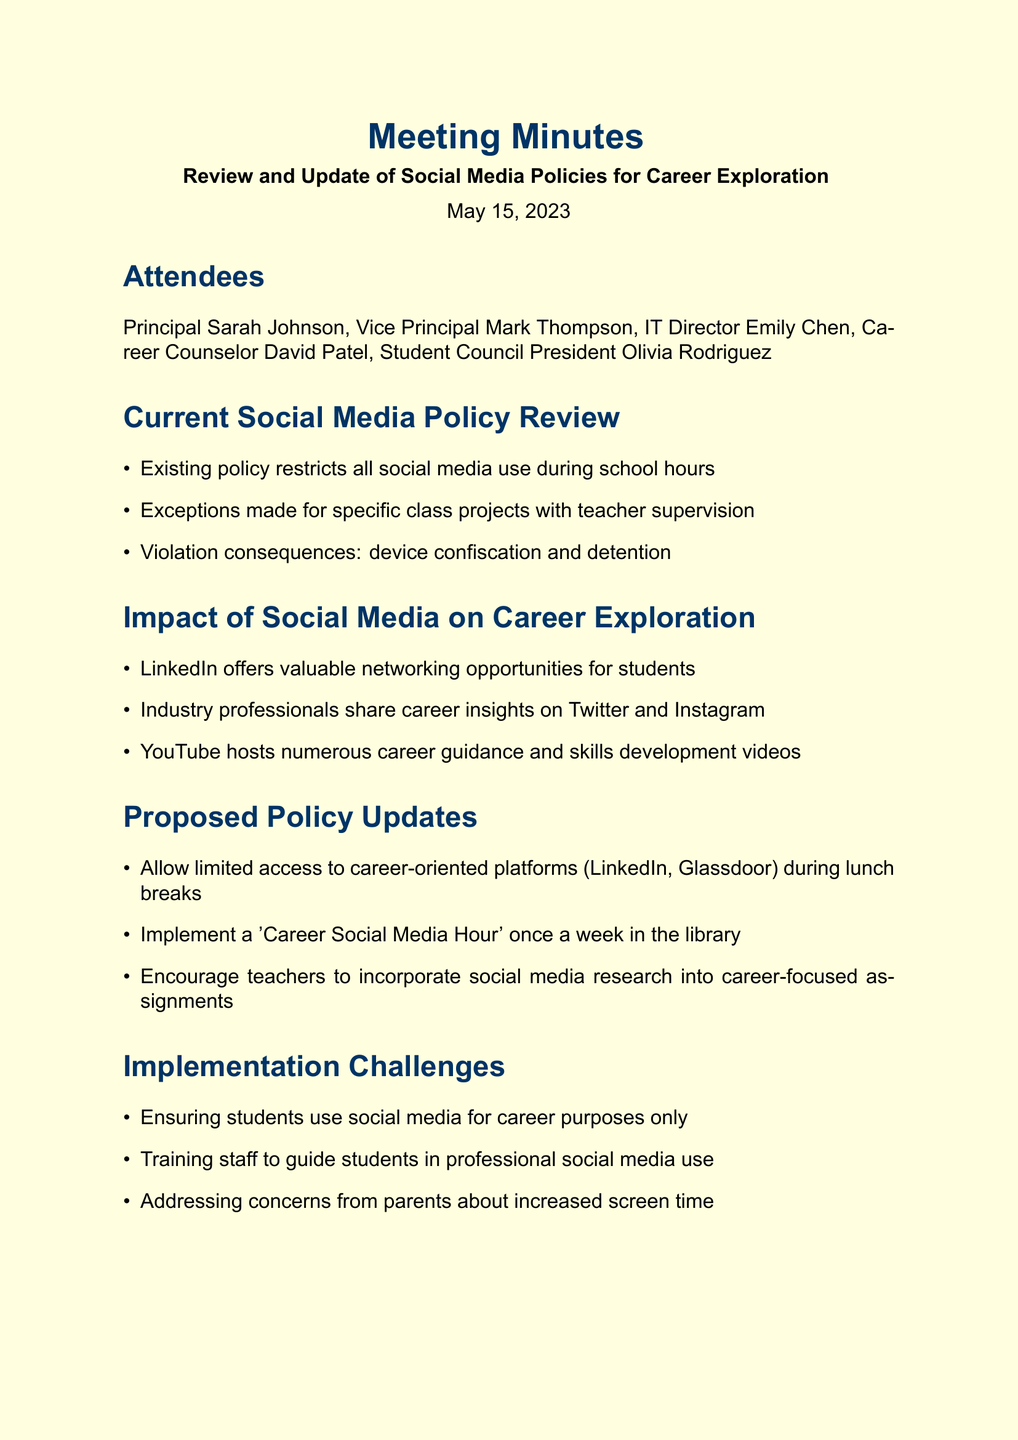what is the date of the meeting? The date of the meeting is explicitly mentioned in the document.
Answer: May 15, 2023 who is the IT Director? The document lists the attendees, including their titles, making it clear who the IT Director is.
Answer: Emily Chen what are the consequences of violating the current social media policy? The document outlines the consequences of violations in the current policy section.
Answer: device confiscation and detention what is one platform that offers networking opportunities for students? The document discusses the impact of social media on career exploration and mentions specific platforms.
Answer: LinkedIn how often is the proposed 'Career Social Media Hour' planned to occur? This information is found in the proposed policy updates section regarding the frequency of the event.
Answer: once a week what is the next step related to the Parent-Teacher Association? The next steps are provided in the document, outlining actions to take after the meeting.
Answer: Schedule meeting state a challenge mentioned regarding the implementation of the proposed updates. The document lists challenges in the implementation section, each focusing on different aspects of social media use.
Answer: Ensuring students use social media for career purposes only who was the Student Council President in the meeting? The names and titles of attendees are listed in the document, identifying the role of the Student Council President.
Answer: Olivia Rodriguez 